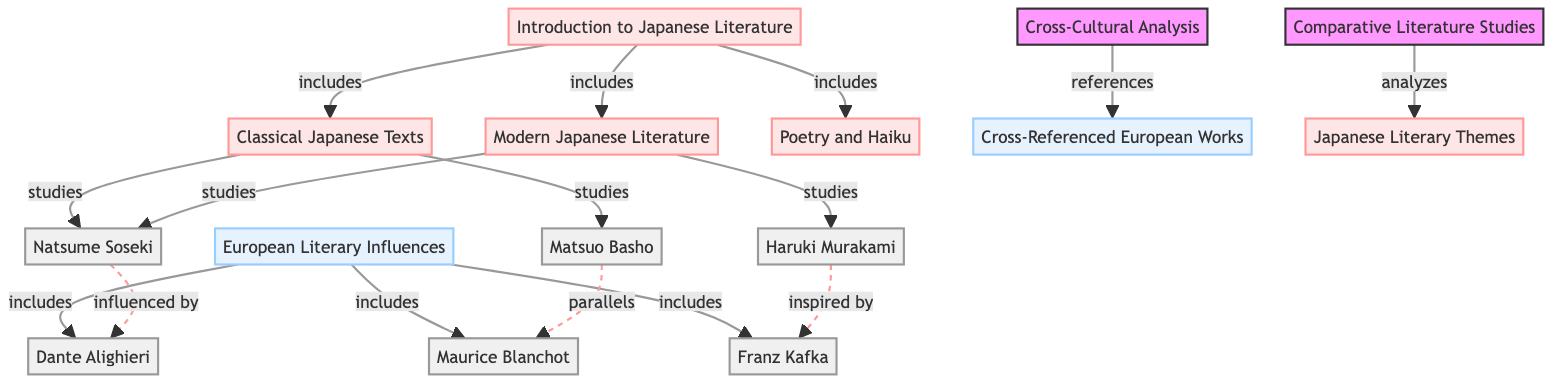What is the first topic introduced in the Japanese Literature curriculum? The diagram lists "Introduction to Japanese Literature" as the starting point, which indicates it is the first topic of study.
Answer: Introduction to Japanese Literature How many major areas are included under the introduction? The diagram shows that the "Introduction to Japanese Literature" includes three specific areas: "Classical Japanese Texts," "Modern Japanese Literature," and "Poetry and Haiku." Counting these gives a total of three areas.
Answer: 3 Which European literary figure is referenced as being influenced by Natsume Soseki? The diagram indicates a dashed line showing the influence of Natsume Soseki, pointing to Dante Alighieri, suggesting that Soseki was influenced by this European author.
Answer: Dante Alighieri Which node is related to comparative literature studies? The "Comparative Literature Studies" node connects to "Japanese Literary Themes," indicating it is the focus of that node within the curriculum structure.
Answer: Comparative Literature Studies How many authors are named in the curriculum? The diagram lists six distinct authors' names, including Natsume Soseki, Haruki Murakami, Matsuo Basho, Dante Alighieri, Franz Kafka, and Maurice Blanchot. Therefore, the count of authors is six.
Answer: 6 Which aspect of literature does "Cross-Cultural Analysis" reference? The specific edge leading from "Cross-Cultural Analysis" references "Cross-Referenced European Works," indicating that it discusses or analyzes these European works within a cross-cultural context.
Answer: Cross-Referenced European Works What theme is examined through comparative literature studies? The diagram shows that "Comparative Literature Studies" analyzes "Japanese Literary Themes," thus indicating that the examination is focused on this specific aspect of literature.
Answer: Japanese Literary Themes Which Japanese literary work studies modern Japanese literature? The node "Modern Japanese Literature" specifically studies works attributed to Haruki Murakami, establishing his relevance in this literary area.
Answer: Haruki Murakami What relationship exists between Matsuo Basho and Maurice Blanchot in the curriculum? The diagram highlights a dashed line indicating a "parallels" relationship between Matsuo Basho and Maurice Blanchot, showing that their works or themes are compared or seen as similar.
Answer: parallels 